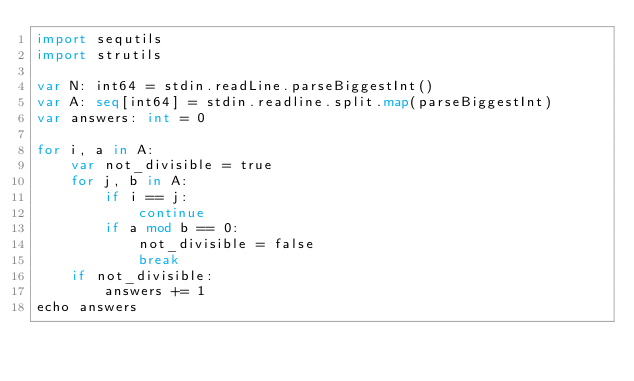<code> <loc_0><loc_0><loc_500><loc_500><_Nim_>import sequtils
import strutils

var N: int64 = stdin.readLine.parseBiggestInt()
var A: seq[int64] = stdin.readline.split.map(parseBiggestInt)
var answers: int = 0

for i, a in A:
    var not_divisible = true
    for j, b in A:
        if i == j:
            continue
        if a mod b == 0:
            not_divisible = false
            break
    if not_divisible:
        answers += 1
echo answers</code> 